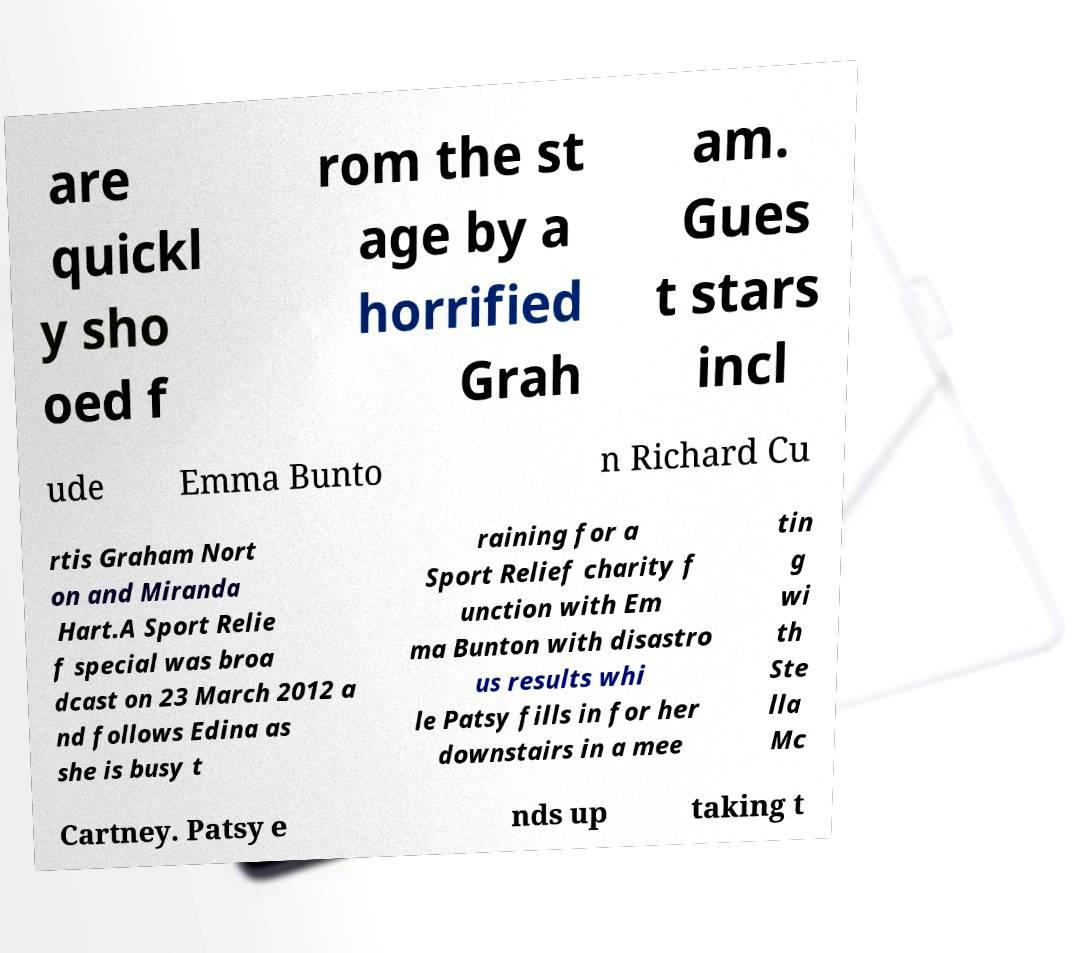I need the written content from this picture converted into text. Can you do that? are quickl y sho oed f rom the st age by a horrified Grah am. Gues t stars incl ude Emma Bunto n Richard Cu rtis Graham Nort on and Miranda Hart.A Sport Relie f special was broa dcast on 23 March 2012 a nd follows Edina as she is busy t raining for a Sport Relief charity f unction with Em ma Bunton with disastro us results whi le Patsy fills in for her downstairs in a mee tin g wi th Ste lla Mc Cartney. Patsy e nds up taking t 